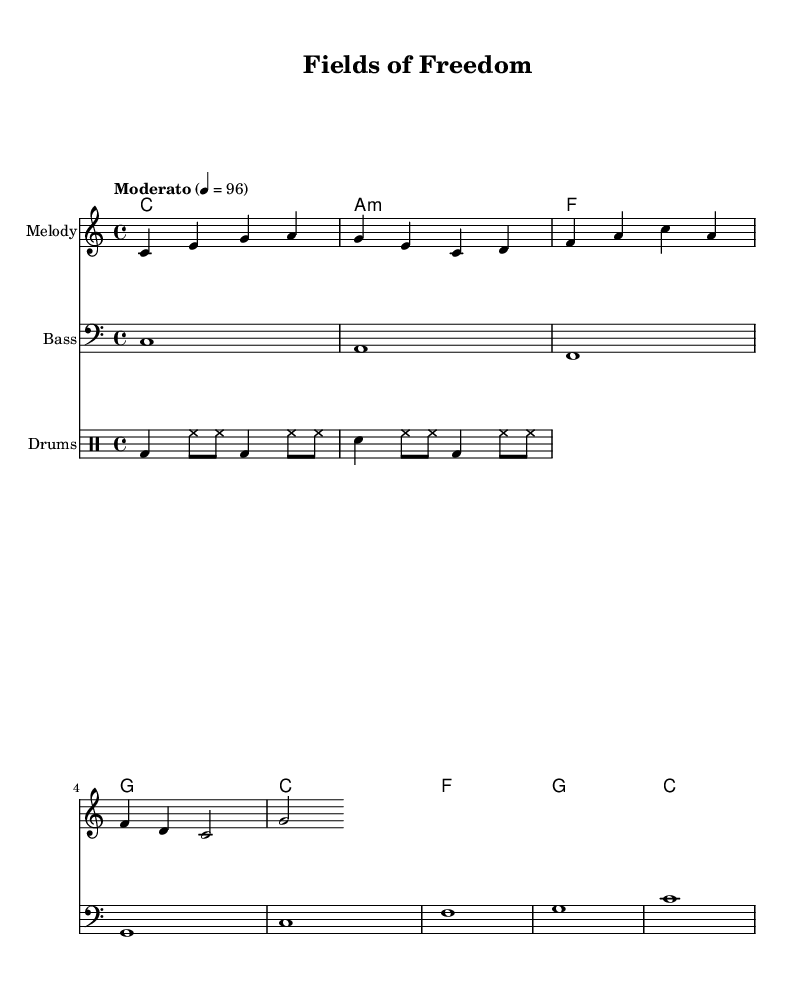What is the key signature of this music? The key signature is shown at the beginning of the score and indicates the tonal center of C major, which has no sharps or flats.
Answer: C major What is the time signature of this music? The time signature is found in the score right after the key signature, and it indicates that there are four beats in each measure (4/4 time).
Answer: 4/4 What is the tempo marking for this piece? The tempo marking appears at the start of the score, stating "Moderato" with a metronome marking of quarter note equals 96, which indicates a moderate speed.
Answer: Moderato, 4 = 96 How many measures are in the melody? By counting the phrases in the melody part, there are a total of four measures. Each line of the melody represents a measure.
Answer: 4 What is the primary theme of the lyrics? The lyrics emphasize working in the fields and nurturing seeds of hope, reflecting a strong connection to rural and agricultural life.
Answer: Working in the fields Which chord appears most frequently in the harmonies? By analyzing the chord progression, the C major chord occurs multiple times throughout the score, indicating its prominence in the piece.
Answer: C What musical genre does this piece represent? The style and thematic content, including the soulful lyrics and harmonic structure, align with the Rhythm and Blues genre, particularly focusing on rural life and agriculture.
Answer: Rhythm and Blues 